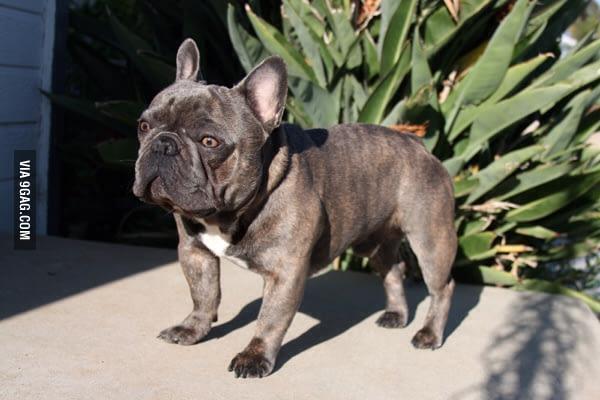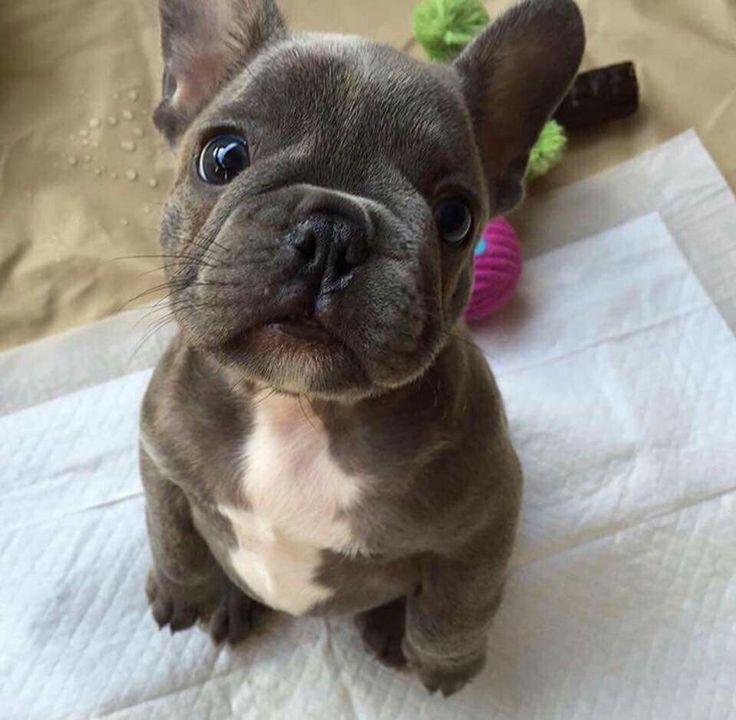The first image is the image on the left, the second image is the image on the right. Assess this claim about the two images: "At least one image features a puppy on the grass.". Correct or not? Answer yes or no. No. 